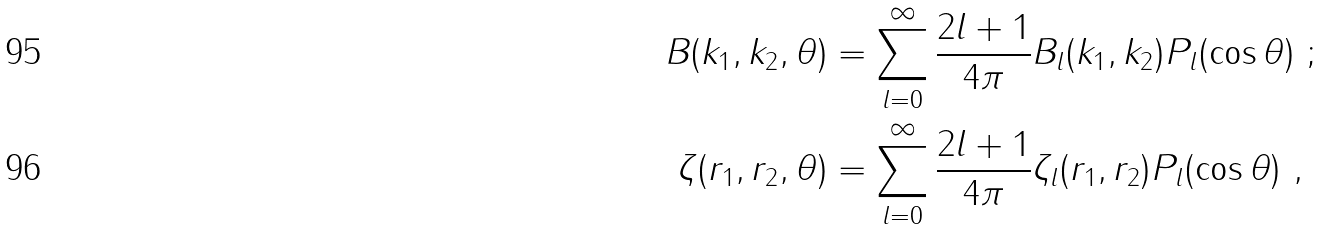<formula> <loc_0><loc_0><loc_500><loc_500>B ( k _ { 1 } , k _ { 2 } , \theta ) & = \sum _ { l = 0 } ^ { \infty } \frac { 2 l + 1 } { 4 \pi } B _ { l } ( k _ { 1 } , k _ { 2 } ) P _ { l } ( \cos \theta ) \ ; \\ \zeta ( r _ { 1 } , r _ { 2 } , \theta ) & = \sum _ { l = 0 } ^ { \infty } \frac { 2 l + 1 } { 4 \pi } \zeta _ { l } ( r _ { 1 } , r _ { 2 } ) P _ { l } ( \cos \theta ) \ ,</formula> 